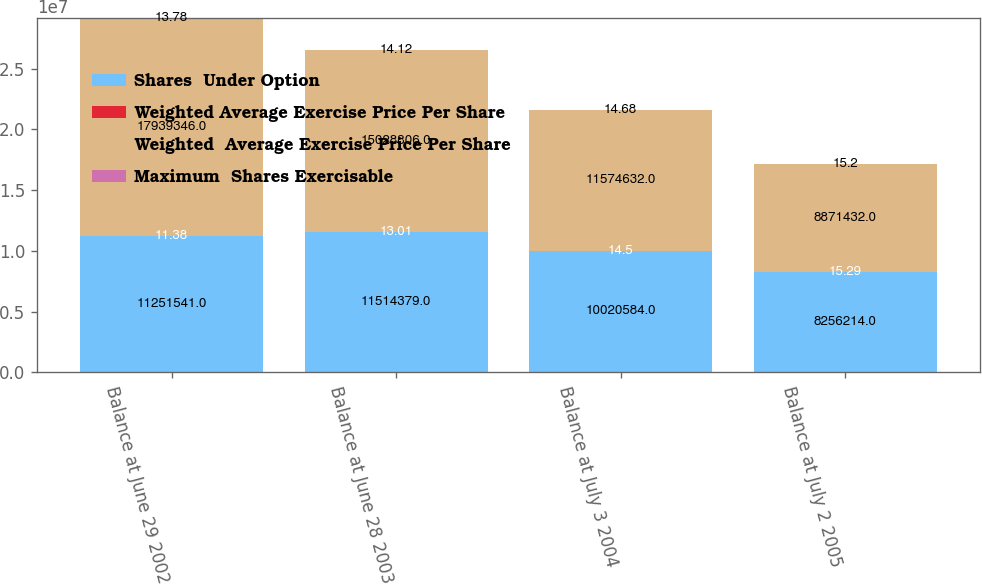<chart> <loc_0><loc_0><loc_500><loc_500><stacked_bar_chart><ecel><fcel>Balance at June 29 2002<fcel>Balance at June 28 2003<fcel>Balance at July 3 2004<fcel>Balance at July 2 2005<nl><fcel>Shares  Under Option<fcel>1.12515e+07<fcel>1.15144e+07<fcel>1.00206e+07<fcel>8.25621e+06<nl><fcel>Weighted Average Exercise Price Per Share<fcel>11.38<fcel>13.01<fcel>14.5<fcel>15.29<nl><fcel>Weighted  Average Exercise Price Per Share<fcel>1.79393e+07<fcel>1.50288e+07<fcel>1.15746e+07<fcel>8.87143e+06<nl><fcel>Maximum  Shares Exercisable<fcel>13.78<fcel>14.12<fcel>14.68<fcel>15.2<nl></chart> 